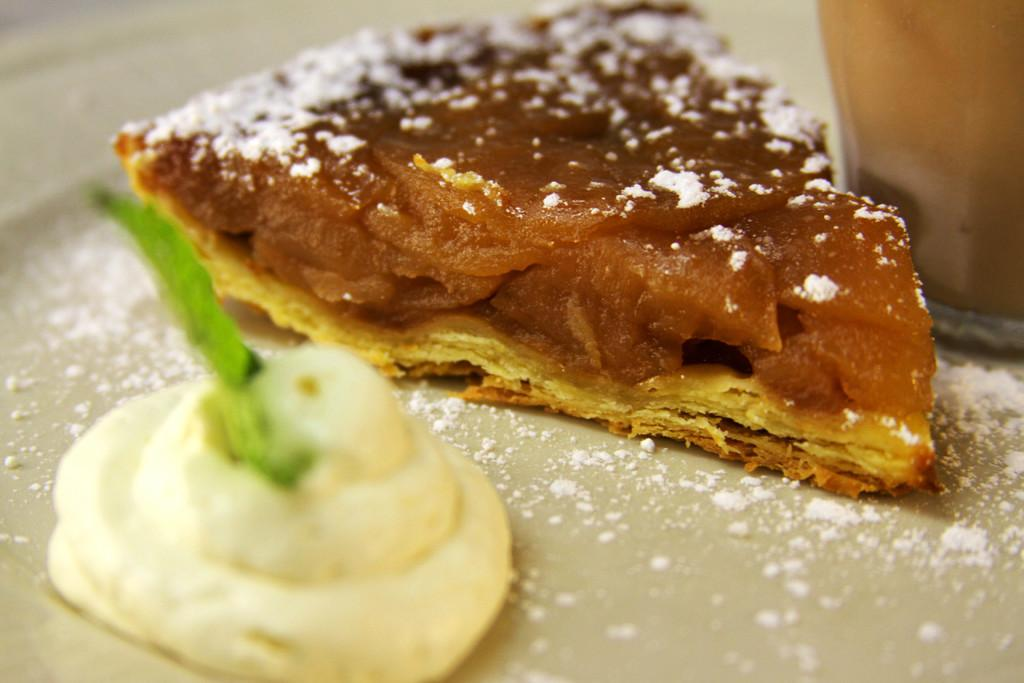What type of food item is depicted in the image? There is a slice of a food item in the image. What is covering the food item? There is cream on the food item. What is placed on top of the cream? There is a leaf on top of the cream. What holiday is being celebrated in the image? There is no indication of a holiday being celebrated in the image. How many fingers can be seen holding the food item in the image? There are no fingers visible in the image; it only shows a slice of a food item with cream and a leaf on top. 